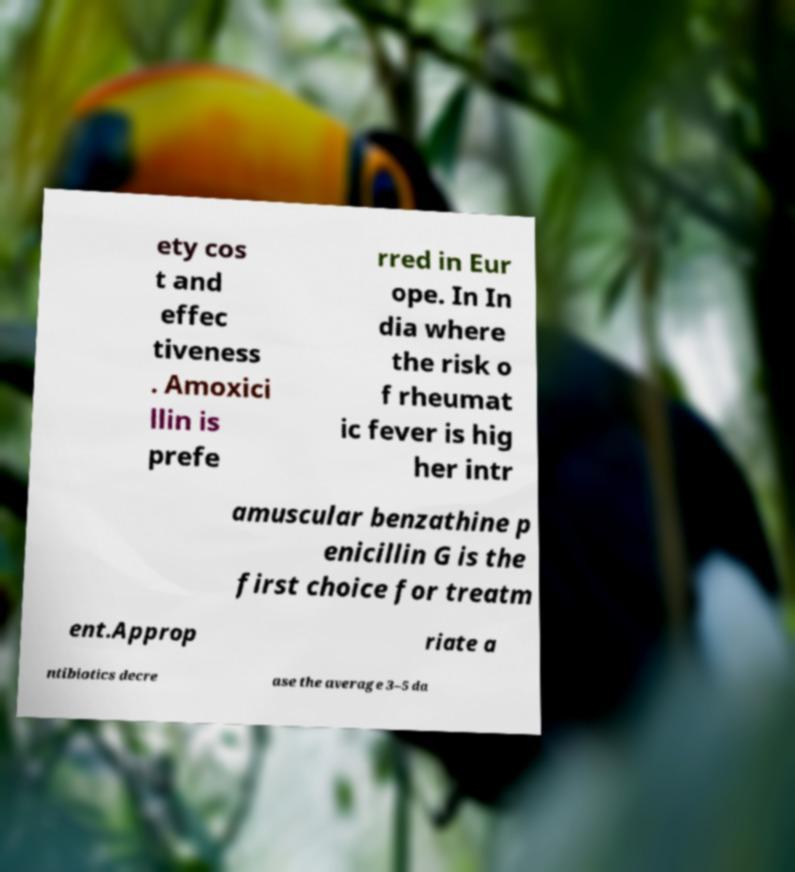For documentation purposes, I need the text within this image transcribed. Could you provide that? ety cos t and effec tiveness . Amoxici llin is prefe rred in Eur ope. In In dia where the risk o f rheumat ic fever is hig her intr amuscular benzathine p enicillin G is the first choice for treatm ent.Approp riate a ntibiotics decre ase the average 3–5 da 